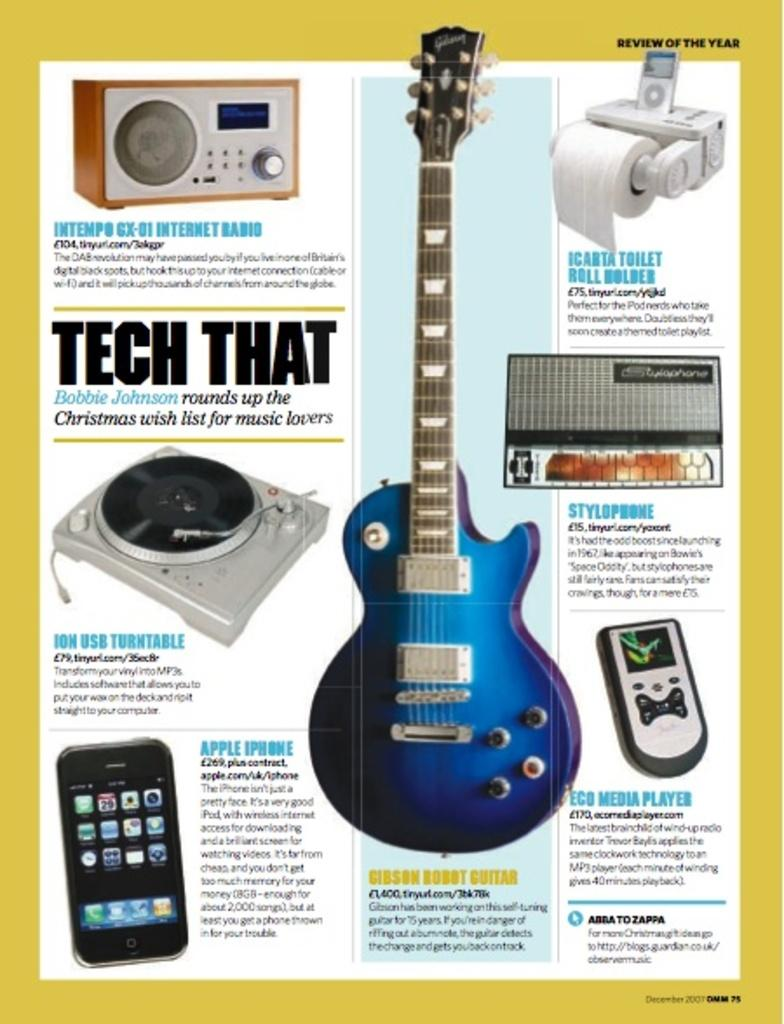<image>
Create a compact narrative representing the image presented. Innovative products on a review of the year page fro the likes of Gibson guitars and Eco 